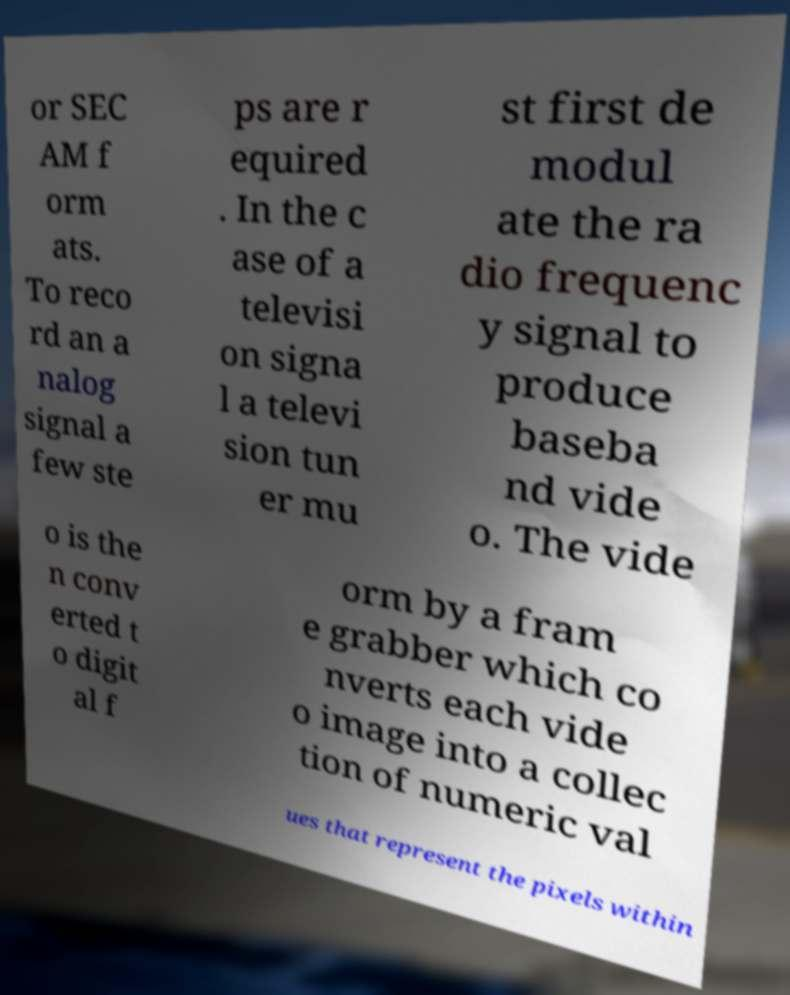Could you extract and type out the text from this image? or SEC AM f orm ats. To reco rd an a nalog signal a few ste ps are r equired . In the c ase of a televisi on signa l a televi sion tun er mu st first de modul ate the ra dio frequenc y signal to produce baseba nd vide o. The vide o is the n conv erted t o digit al f orm by a fram e grabber which co nverts each vide o image into a collec tion of numeric val ues that represent the pixels within 